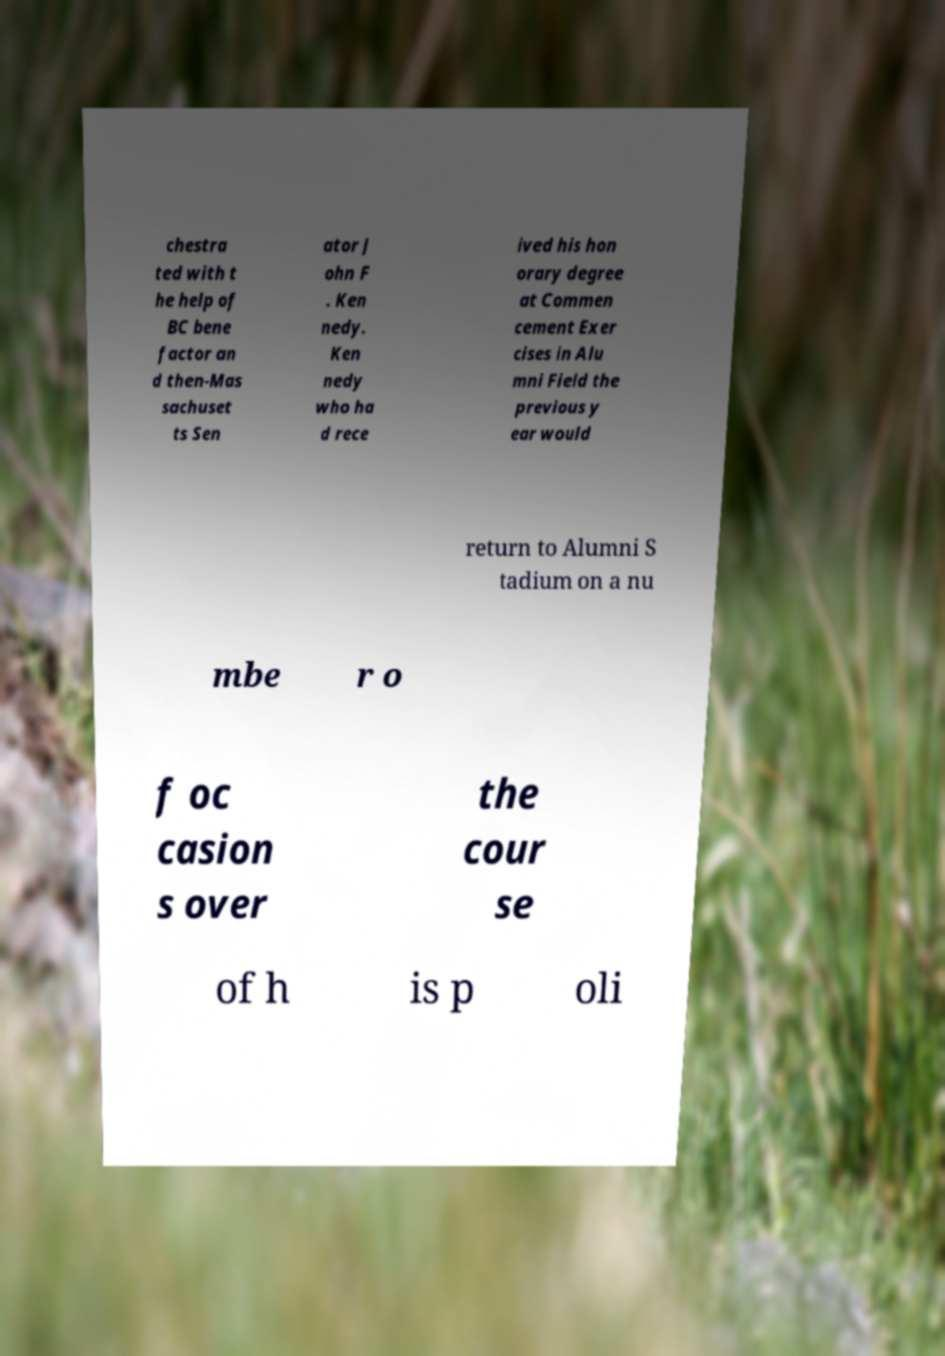Please identify and transcribe the text found in this image. chestra ted with t he help of BC bene factor an d then-Mas sachuset ts Sen ator J ohn F . Ken nedy. Ken nedy who ha d rece ived his hon orary degree at Commen cement Exer cises in Alu mni Field the previous y ear would return to Alumni S tadium on a nu mbe r o f oc casion s over the cour se of h is p oli 